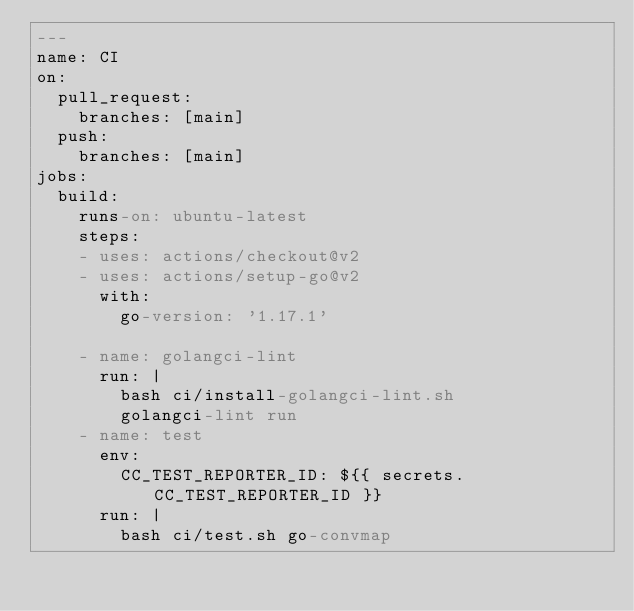<code> <loc_0><loc_0><loc_500><loc_500><_YAML_>---
name: CI
on:
  pull_request:
    branches: [main]
  push:
    branches: [main]
jobs:
  build:
    runs-on: ubuntu-latest
    steps:
    - uses: actions/checkout@v2
    - uses: actions/setup-go@v2
      with:
        go-version: '1.17.1'

    - name: golangci-lint
      run: |
        bash ci/install-golangci-lint.sh
        golangci-lint run
    - name: test
      env:
        CC_TEST_REPORTER_ID: ${{ secrets.CC_TEST_REPORTER_ID }}
      run: |
        bash ci/test.sh go-convmap
</code> 